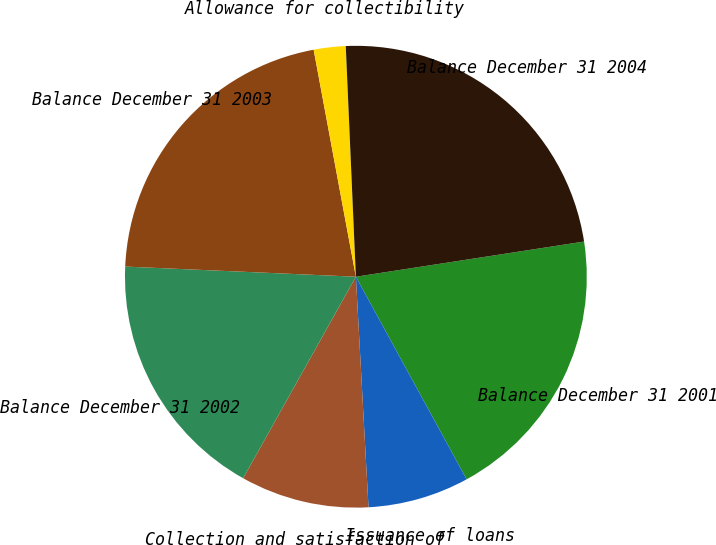Convert chart to OTSL. <chart><loc_0><loc_0><loc_500><loc_500><pie_chart><fcel>Balance December 31 2001<fcel>Issuance of loans<fcel>Collection and satisfaction of<fcel>Balance December 31 2002<fcel>Balance December 31 2003<fcel>Allowance for collectibility<fcel>Balance December 31 2004<nl><fcel>19.47%<fcel>7.09%<fcel>8.99%<fcel>17.58%<fcel>21.37%<fcel>2.23%<fcel>23.26%<nl></chart> 